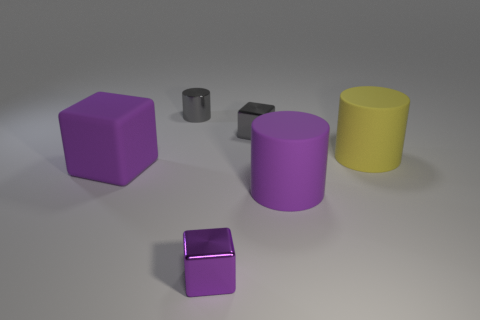There is a purple thing that is both in front of the big cube and to the left of the purple cylinder; what material is it made of?
Keep it short and to the point. Metal. Are there any other things that are the same color as the small cylinder?
Offer a very short reply. Yes. Is the number of big rubber things left of the purple metal thing less than the number of brown balls?
Your answer should be very brief. No. Is the number of big green matte spheres greater than the number of large yellow cylinders?
Provide a succinct answer. No. Are there any yellow matte things that are on the right side of the metallic object that is on the right side of the small metallic thing that is in front of the large yellow thing?
Ensure brevity in your answer.  Yes. How many other objects are the same size as the metallic cylinder?
Keep it short and to the point. 2. There is a large purple cube; are there any large purple things in front of it?
Ensure brevity in your answer.  Yes. Do the tiny metal cylinder and the cylinder that is in front of the large purple rubber block have the same color?
Make the answer very short. No. There is a metallic thing in front of the purple thing that is behind the matte cylinder that is in front of the big yellow cylinder; what color is it?
Provide a short and direct response. Purple. Are there any gray things of the same shape as the small purple object?
Provide a short and direct response. Yes. 